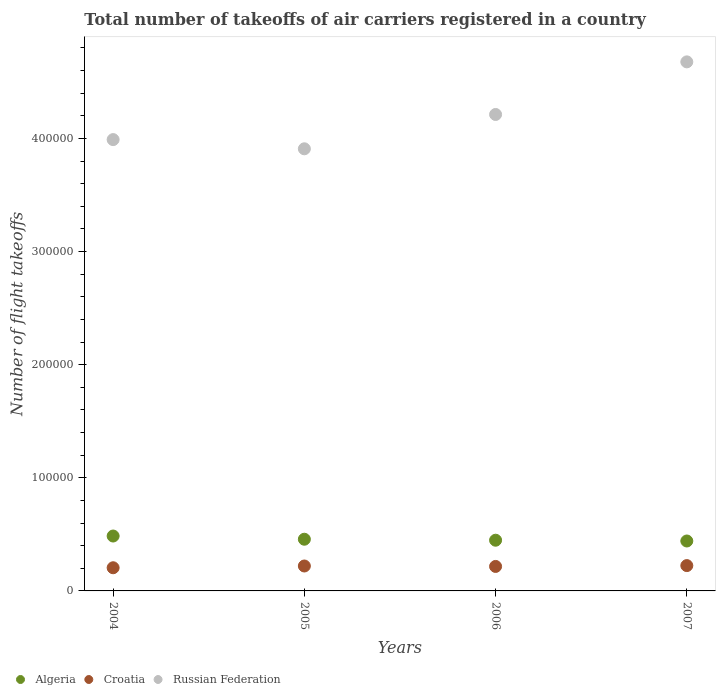How many different coloured dotlines are there?
Give a very brief answer. 3. Is the number of dotlines equal to the number of legend labels?
Offer a very short reply. Yes. What is the total number of flight takeoffs in Russian Federation in 2006?
Offer a terse response. 4.21e+05. Across all years, what is the maximum total number of flight takeoffs in Russian Federation?
Offer a terse response. 4.68e+05. Across all years, what is the minimum total number of flight takeoffs in Algeria?
Make the answer very short. 4.41e+04. In which year was the total number of flight takeoffs in Croatia maximum?
Offer a very short reply. 2007. What is the total total number of flight takeoffs in Croatia in the graph?
Ensure brevity in your answer.  8.65e+04. What is the difference between the total number of flight takeoffs in Croatia in 2006 and that in 2007?
Your answer should be very brief. -750. What is the difference between the total number of flight takeoffs in Algeria in 2005 and the total number of flight takeoffs in Croatia in 2007?
Keep it short and to the point. 2.33e+04. What is the average total number of flight takeoffs in Croatia per year?
Make the answer very short. 2.16e+04. In the year 2006, what is the difference between the total number of flight takeoffs in Russian Federation and total number of flight takeoffs in Croatia?
Ensure brevity in your answer.  4.00e+05. In how many years, is the total number of flight takeoffs in Russian Federation greater than 80000?
Offer a terse response. 4. What is the ratio of the total number of flight takeoffs in Croatia in 2004 to that in 2006?
Your response must be concise. 0.95. Is the total number of flight takeoffs in Algeria in 2006 less than that in 2007?
Ensure brevity in your answer.  No. What is the difference between the highest and the second highest total number of flight takeoffs in Algeria?
Make the answer very short. 2839. What is the difference between the highest and the lowest total number of flight takeoffs in Russian Federation?
Offer a very short reply. 7.68e+04. In how many years, is the total number of flight takeoffs in Russian Federation greater than the average total number of flight takeoffs in Russian Federation taken over all years?
Give a very brief answer. 2. Is it the case that in every year, the sum of the total number of flight takeoffs in Russian Federation and total number of flight takeoffs in Croatia  is greater than the total number of flight takeoffs in Algeria?
Your answer should be compact. Yes. Is the total number of flight takeoffs in Croatia strictly less than the total number of flight takeoffs in Algeria over the years?
Your answer should be very brief. Yes. What is the difference between two consecutive major ticks on the Y-axis?
Offer a terse response. 1.00e+05. Does the graph contain grids?
Ensure brevity in your answer.  No. Where does the legend appear in the graph?
Your answer should be compact. Bottom left. How many legend labels are there?
Offer a terse response. 3. How are the legend labels stacked?
Keep it short and to the point. Horizontal. What is the title of the graph?
Your answer should be very brief. Total number of takeoffs of air carriers registered in a country. What is the label or title of the Y-axis?
Offer a very short reply. Number of flight takeoffs. What is the Number of flight takeoffs of Algeria in 2004?
Keep it short and to the point. 4.85e+04. What is the Number of flight takeoffs in Croatia in 2004?
Your answer should be compact. 2.05e+04. What is the Number of flight takeoffs in Russian Federation in 2004?
Ensure brevity in your answer.  3.99e+05. What is the Number of flight takeoffs in Algeria in 2005?
Provide a succinct answer. 4.57e+04. What is the Number of flight takeoffs of Croatia in 2005?
Provide a succinct answer. 2.20e+04. What is the Number of flight takeoffs of Russian Federation in 2005?
Your answer should be very brief. 3.91e+05. What is the Number of flight takeoffs of Algeria in 2006?
Your answer should be compact. 4.48e+04. What is the Number of flight takeoffs in Croatia in 2006?
Offer a very short reply. 2.16e+04. What is the Number of flight takeoffs in Russian Federation in 2006?
Offer a very short reply. 4.21e+05. What is the Number of flight takeoffs in Algeria in 2007?
Provide a succinct answer. 4.41e+04. What is the Number of flight takeoffs in Croatia in 2007?
Provide a short and direct response. 2.24e+04. What is the Number of flight takeoffs of Russian Federation in 2007?
Your answer should be compact. 4.68e+05. Across all years, what is the maximum Number of flight takeoffs in Algeria?
Give a very brief answer. 4.85e+04. Across all years, what is the maximum Number of flight takeoffs in Croatia?
Your answer should be compact. 2.24e+04. Across all years, what is the maximum Number of flight takeoffs in Russian Federation?
Ensure brevity in your answer.  4.68e+05. Across all years, what is the minimum Number of flight takeoffs of Algeria?
Your response must be concise. 4.41e+04. Across all years, what is the minimum Number of flight takeoffs in Croatia?
Your response must be concise. 2.05e+04. Across all years, what is the minimum Number of flight takeoffs in Russian Federation?
Offer a very short reply. 3.91e+05. What is the total Number of flight takeoffs of Algeria in the graph?
Keep it short and to the point. 1.83e+05. What is the total Number of flight takeoffs of Croatia in the graph?
Your answer should be very brief. 8.65e+04. What is the total Number of flight takeoffs in Russian Federation in the graph?
Keep it short and to the point. 1.68e+06. What is the difference between the Number of flight takeoffs in Algeria in 2004 and that in 2005?
Make the answer very short. 2839. What is the difference between the Number of flight takeoffs in Croatia in 2004 and that in 2005?
Your answer should be compact. -1549. What is the difference between the Number of flight takeoffs of Russian Federation in 2004 and that in 2005?
Ensure brevity in your answer.  8134. What is the difference between the Number of flight takeoffs in Algeria in 2004 and that in 2006?
Make the answer very short. 3709. What is the difference between the Number of flight takeoffs of Croatia in 2004 and that in 2006?
Your response must be concise. -1159. What is the difference between the Number of flight takeoffs of Russian Federation in 2004 and that in 2006?
Give a very brief answer. -2.22e+04. What is the difference between the Number of flight takeoffs in Algeria in 2004 and that in 2007?
Your answer should be very brief. 4395. What is the difference between the Number of flight takeoffs in Croatia in 2004 and that in 2007?
Provide a succinct answer. -1909. What is the difference between the Number of flight takeoffs of Russian Federation in 2004 and that in 2007?
Provide a succinct answer. -6.87e+04. What is the difference between the Number of flight takeoffs in Algeria in 2005 and that in 2006?
Keep it short and to the point. 870. What is the difference between the Number of flight takeoffs of Croatia in 2005 and that in 2006?
Provide a short and direct response. 390. What is the difference between the Number of flight takeoffs in Russian Federation in 2005 and that in 2006?
Keep it short and to the point. -3.03e+04. What is the difference between the Number of flight takeoffs in Algeria in 2005 and that in 2007?
Your response must be concise. 1556. What is the difference between the Number of flight takeoffs in Croatia in 2005 and that in 2007?
Your answer should be compact. -360. What is the difference between the Number of flight takeoffs of Russian Federation in 2005 and that in 2007?
Your response must be concise. -7.68e+04. What is the difference between the Number of flight takeoffs of Algeria in 2006 and that in 2007?
Provide a short and direct response. 686. What is the difference between the Number of flight takeoffs in Croatia in 2006 and that in 2007?
Keep it short and to the point. -750. What is the difference between the Number of flight takeoffs in Russian Federation in 2006 and that in 2007?
Offer a very short reply. -4.65e+04. What is the difference between the Number of flight takeoffs of Algeria in 2004 and the Number of flight takeoffs of Croatia in 2005?
Your response must be concise. 2.65e+04. What is the difference between the Number of flight takeoffs in Algeria in 2004 and the Number of flight takeoffs in Russian Federation in 2005?
Your answer should be compact. -3.42e+05. What is the difference between the Number of flight takeoffs of Croatia in 2004 and the Number of flight takeoffs of Russian Federation in 2005?
Offer a terse response. -3.70e+05. What is the difference between the Number of flight takeoffs in Algeria in 2004 and the Number of flight takeoffs in Croatia in 2006?
Provide a short and direct response. 2.69e+04. What is the difference between the Number of flight takeoffs of Algeria in 2004 and the Number of flight takeoffs of Russian Federation in 2006?
Offer a very short reply. -3.73e+05. What is the difference between the Number of flight takeoffs of Croatia in 2004 and the Number of flight takeoffs of Russian Federation in 2006?
Your response must be concise. -4.01e+05. What is the difference between the Number of flight takeoffs in Algeria in 2004 and the Number of flight takeoffs in Croatia in 2007?
Provide a succinct answer. 2.61e+04. What is the difference between the Number of flight takeoffs of Algeria in 2004 and the Number of flight takeoffs of Russian Federation in 2007?
Your answer should be very brief. -4.19e+05. What is the difference between the Number of flight takeoffs of Croatia in 2004 and the Number of flight takeoffs of Russian Federation in 2007?
Offer a very short reply. -4.47e+05. What is the difference between the Number of flight takeoffs in Algeria in 2005 and the Number of flight takeoffs in Croatia in 2006?
Your answer should be compact. 2.41e+04. What is the difference between the Number of flight takeoffs in Algeria in 2005 and the Number of flight takeoffs in Russian Federation in 2006?
Your answer should be compact. -3.75e+05. What is the difference between the Number of flight takeoffs of Croatia in 2005 and the Number of flight takeoffs of Russian Federation in 2006?
Give a very brief answer. -3.99e+05. What is the difference between the Number of flight takeoffs of Algeria in 2005 and the Number of flight takeoffs of Croatia in 2007?
Provide a succinct answer. 2.33e+04. What is the difference between the Number of flight takeoffs in Algeria in 2005 and the Number of flight takeoffs in Russian Federation in 2007?
Offer a very short reply. -4.22e+05. What is the difference between the Number of flight takeoffs in Croatia in 2005 and the Number of flight takeoffs in Russian Federation in 2007?
Your answer should be very brief. -4.46e+05. What is the difference between the Number of flight takeoffs in Algeria in 2006 and the Number of flight takeoffs in Croatia in 2007?
Provide a short and direct response. 2.24e+04. What is the difference between the Number of flight takeoffs of Algeria in 2006 and the Number of flight takeoffs of Russian Federation in 2007?
Give a very brief answer. -4.23e+05. What is the difference between the Number of flight takeoffs of Croatia in 2006 and the Number of flight takeoffs of Russian Federation in 2007?
Keep it short and to the point. -4.46e+05. What is the average Number of flight takeoffs in Algeria per year?
Keep it short and to the point. 4.58e+04. What is the average Number of flight takeoffs of Croatia per year?
Provide a short and direct response. 2.16e+04. What is the average Number of flight takeoffs of Russian Federation per year?
Provide a succinct answer. 4.20e+05. In the year 2004, what is the difference between the Number of flight takeoffs in Algeria and Number of flight takeoffs in Croatia?
Ensure brevity in your answer.  2.80e+04. In the year 2004, what is the difference between the Number of flight takeoffs of Algeria and Number of flight takeoffs of Russian Federation?
Your answer should be very brief. -3.50e+05. In the year 2004, what is the difference between the Number of flight takeoffs in Croatia and Number of flight takeoffs in Russian Federation?
Give a very brief answer. -3.78e+05. In the year 2005, what is the difference between the Number of flight takeoffs in Algeria and Number of flight takeoffs in Croatia?
Your answer should be very brief. 2.37e+04. In the year 2005, what is the difference between the Number of flight takeoffs of Algeria and Number of flight takeoffs of Russian Federation?
Offer a very short reply. -3.45e+05. In the year 2005, what is the difference between the Number of flight takeoffs in Croatia and Number of flight takeoffs in Russian Federation?
Offer a terse response. -3.69e+05. In the year 2006, what is the difference between the Number of flight takeoffs in Algeria and Number of flight takeoffs in Croatia?
Your answer should be compact. 2.32e+04. In the year 2006, what is the difference between the Number of flight takeoffs in Algeria and Number of flight takeoffs in Russian Federation?
Offer a very short reply. -3.76e+05. In the year 2006, what is the difference between the Number of flight takeoffs in Croatia and Number of flight takeoffs in Russian Federation?
Provide a succinct answer. -4.00e+05. In the year 2007, what is the difference between the Number of flight takeoffs in Algeria and Number of flight takeoffs in Croatia?
Offer a terse response. 2.17e+04. In the year 2007, what is the difference between the Number of flight takeoffs in Algeria and Number of flight takeoffs in Russian Federation?
Offer a very short reply. -4.24e+05. In the year 2007, what is the difference between the Number of flight takeoffs in Croatia and Number of flight takeoffs in Russian Federation?
Ensure brevity in your answer.  -4.45e+05. What is the ratio of the Number of flight takeoffs of Algeria in 2004 to that in 2005?
Your response must be concise. 1.06. What is the ratio of the Number of flight takeoffs of Croatia in 2004 to that in 2005?
Offer a very short reply. 0.93. What is the ratio of the Number of flight takeoffs of Russian Federation in 2004 to that in 2005?
Keep it short and to the point. 1.02. What is the ratio of the Number of flight takeoffs of Algeria in 2004 to that in 2006?
Provide a succinct answer. 1.08. What is the ratio of the Number of flight takeoffs in Croatia in 2004 to that in 2006?
Keep it short and to the point. 0.95. What is the ratio of the Number of flight takeoffs of Russian Federation in 2004 to that in 2006?
Provide a short and direct response. 0.95. What is the ratio of the Number of flight takeoffs in Algeria in 2004 to that in 2007?
Your response must be concise. 1.1. What is the ratio of the Number of flight takeoffs in Croatia in 2004 to that in 2007?
Keep it short and to the point. 0.91. What is the ratio of the Number of flight takeoffs of Russian Federation in 2004 to that in 2007?
Your answer should be very brief. 0.85. What is the ratio of the Number of flight takeoffs in Algeria in 2005 to that in 2006?
Keep it short and to the point. 1.02. What is the ratio of the Number of flight takeoffs of Croatia in 2005 to that in 2006?
Make the answer very short. 1.02. What is the ratio of the Number of flight takeoffs in Russian Federation in 2005 to that in 2006?
Provide a succinct answer. 0.93. What is the ratio of the Number of flight takeoffs in Algeria in 2005 to that in 2007?
Keep it short and to the point. 1.04. What is the ratio of the Number of flight takeoffs in Croatia in 2005 to that in 2007?
Make the answer very short. 0.98. What is the ratio of the Number of flight takeoffs of Russian Federation in 2005 to that in 2007?
Keep it short and to the point. 0.84. What is the ratio of the Number of flight takeoffs of Algeria in 2006 to that in 2007?
Give a very brief answer. 1.02. What is the ratio of the Number of flight takeoffs of Croatia in 2006 to that in 2007?
Your answer should be compact. 0.97. What is the ratio of the Number of flight takeoffs in Russian Federation in 2006 to that in 2007?
Provide a succinct answer. 0.9. What is the difference between the highest and the second highest Number of flight takeoffs in Algeria?
Make the answer very short. 2839. What is the difference between the highest and the second highest Number of flight takeoffs of Croatia?
Offer a terse response. 360. What is the difference between the highest and the second highest Number of flight takeoffs in Russian Federation?
Keep it short and to the point. 4.65e+04. What is the difference between the highest and the lowest Number of flight takeoffs in Algeria?
Provide a short and direct response. 4395. What is the difference between the highest and the lowest Number of flight takeoffs in Croatia?
Your response must be concise. 1909. What is the difference between the highest and the lowest Number of flight takeoffs in Russian Federation?
Your answer should be compact. 7.68e+04. 